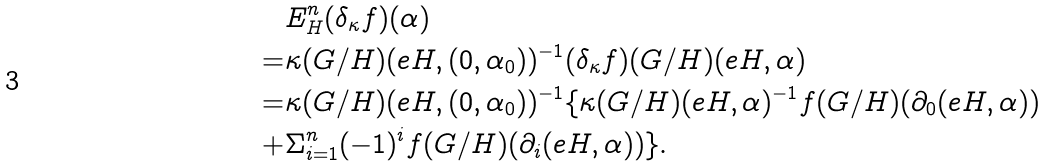<formula> <loc_0><loc_0><loc_500><loc_500>& E ^ { n } _ { H } ( \delta _ { \kappa } f ) ( \alpha ) \\ = & \kappa ( G / H ) ( e H , ( 0 , \alpha _ { 0 } ) ) ^ { - 1 } ( \delta _ { \kappa } f ) ( G / H ) ( e H , \alpha ) \\ = & \kappa ( G / H ) ( e H , ( 0 , \alpha _ { 0 } ) ) ^ { - 1 } \{ \kappa ( G / H ) ( e H , \alpha ) ^ { - 1 } f ( G / H ) ( \partial _ { 0 } ( e H , \alpha ) ) \\ + & \Sigma _ { i = 1 } ^ { n } ( - 1 ) ^ { i } f ( G / H ) ( \partial _ { i } ( e H , \alpha ) ) \} .</formula> 